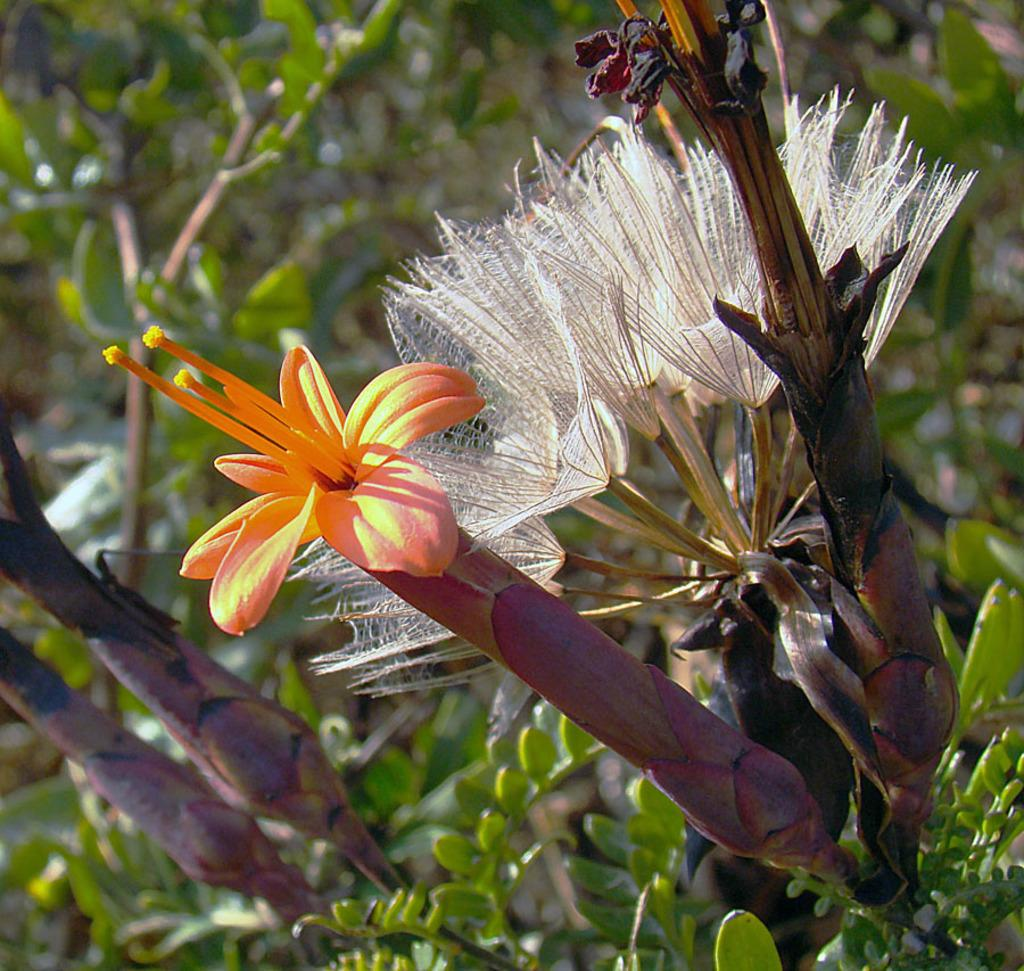What type of living organisms can be seen in the image? Flowers and plants can be seen in the image. Can you describe the background of the image? The background of the image is blurred. Are there any icicles hanging from the flowers in the image? There are no icicles present in the image; it features flowers and plants in a setting that does not suggest the presence of icicles. Can you tell me what time of day the image was taken? The provided facts do not give any information about the time of day the image was taken. 